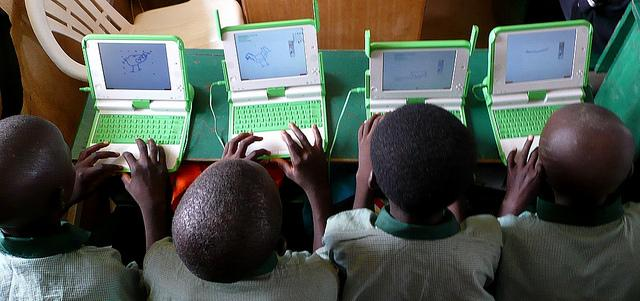Why are all the boys dressed alike?

Choices:
A) for fun
B) they're siblings
C) for halloween
D) dress code dress code 